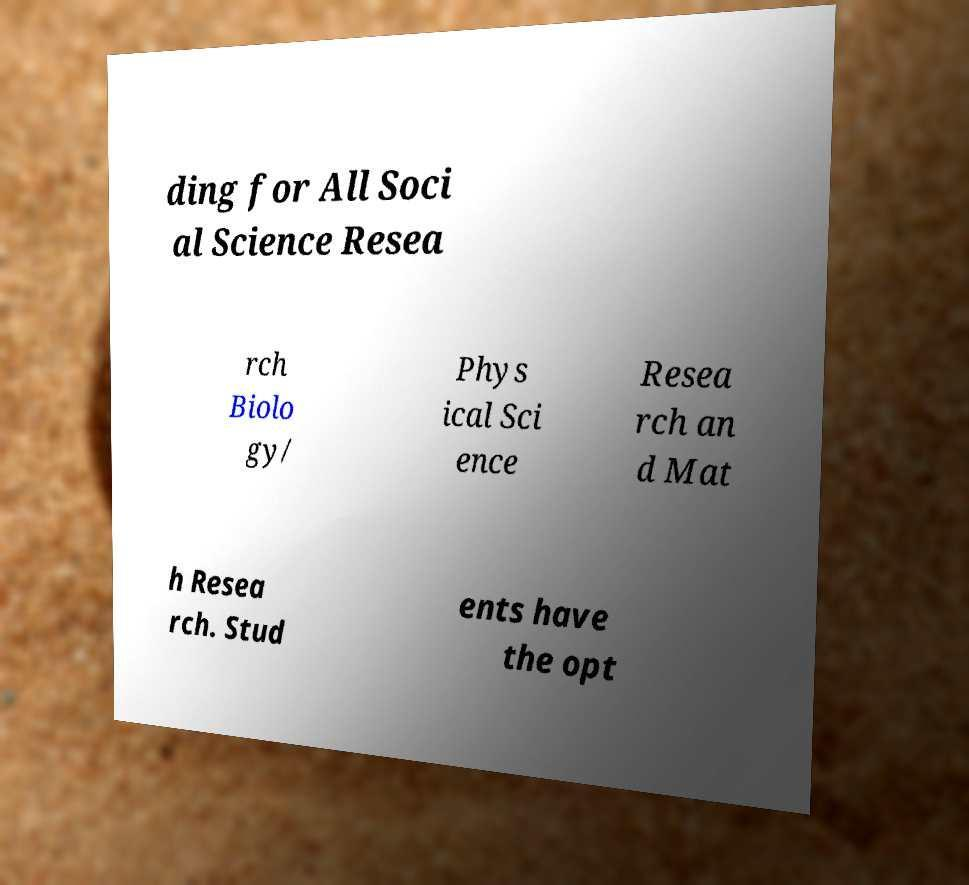Please read and relay the text visible in this image. What does it say? ding for All Soci al Science Resea rch Biolo gy/ Phys ical Sci ence Resea rch an d Mat h Resea rch. Stud ents have the opt 